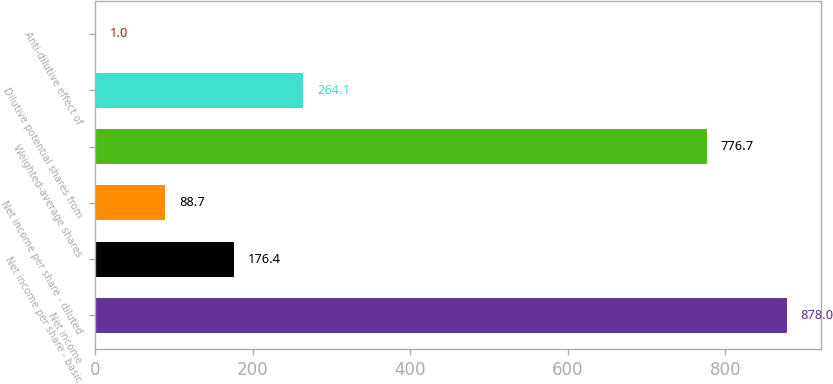Convert chart to OTSL. <chart><loc_0><loc_0><loc_500><loc_500><bar_chart><fcel>Net income<fcel>Net income per share - basic<fcel>Net income per share - diluted<fcel>Weighted-average shares<fcel>Dilutive potential shares from<fcel>Anti-dilutive effect of<nl><fcel>878<fcel>176.4<fcel>88.7<fcel>776.7<fcel>264.1<fcel>1<nl></chart> 